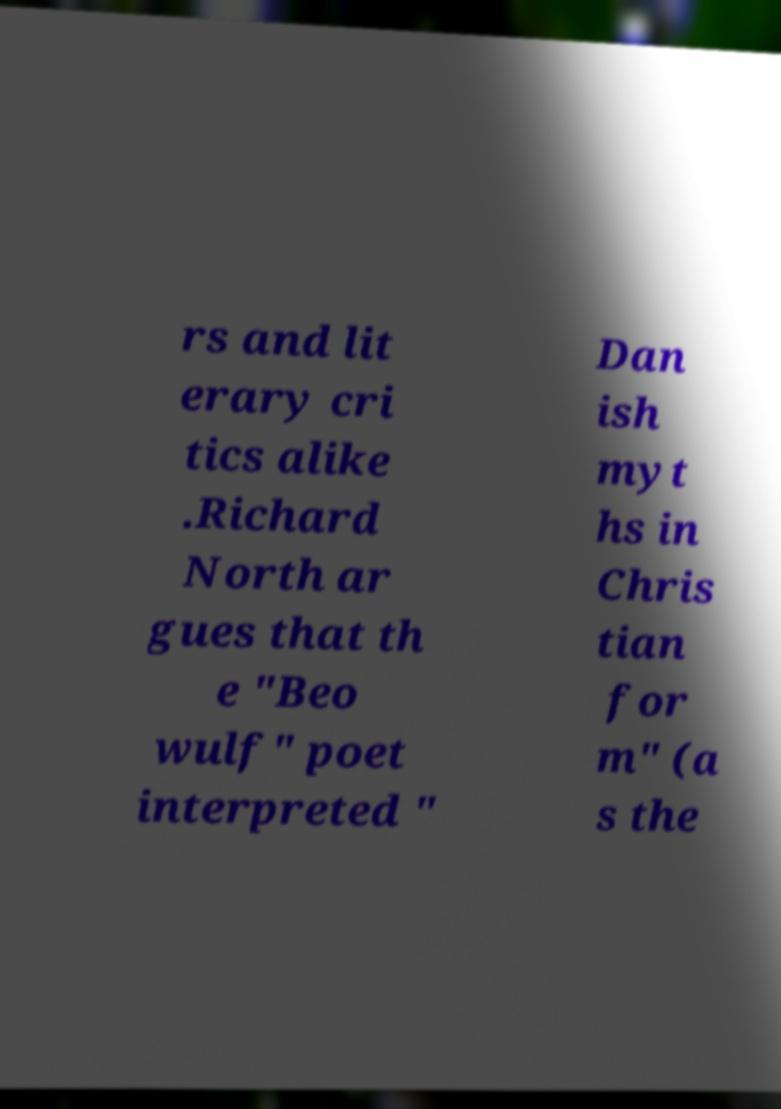Please identify and transcribe the text found in this image. rs and lit erary cri tics alike .Richard North ar gues that th e "Beo wulf" poet interpreted " Dan ish myt hs in Chris tian for m" (a s the 